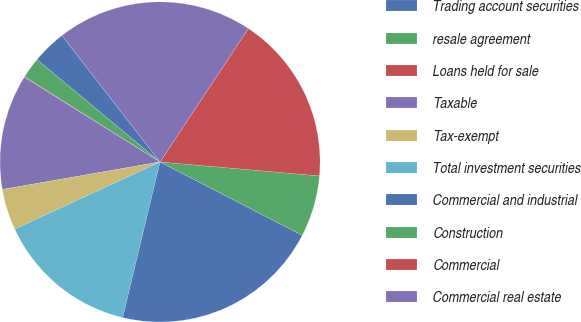Convert chart. <chart><loc_0><loc_0><loc_500><loc_500><pie_chart><fcel>Trading account securities<fcel>resale agreement<fcel>Loans held for sale<fcel>Taxable<fcel>Tax-exempt<fcel>Total investment securities<fcel>Commercial and industrial<fcel>Construction<fcel>Commercial<fcel>Commercial real estate<nl><fcel>3.46%<fcel>2.1%<fcel>0.06%<fcel>11.63%<fcel>4.14%<fcel>14.36%<fcel>21.17%<fcel>6.19%<fcel>17.08%<fcel>19.81%<nl></chart> 